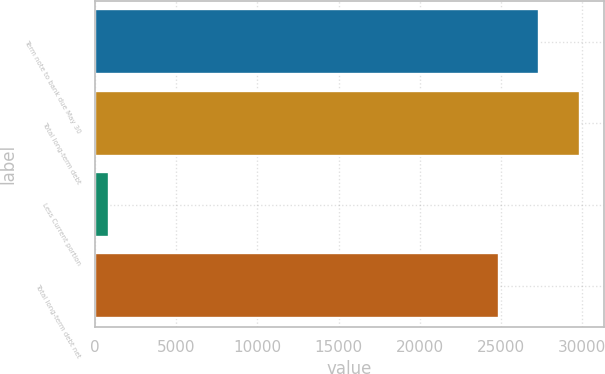Convert chart to OTSL. <chart><loc_0><loc_0><loc_500><loc_500><bar_chart><fcel>Term note to bank due May 30<fcel>Total long-term debt<fcel>Less Current portion<fcel>Total long-term debt net<nl><fcel>27341.6<fcel>29827.2<fcel>886<fcel>24856<nl></chart> 